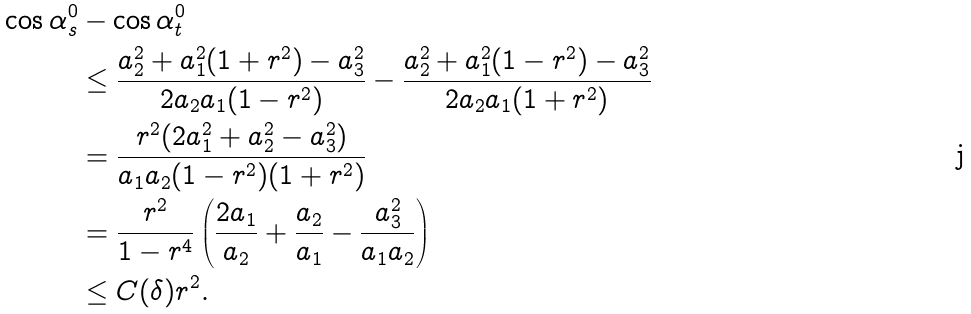<formula> <loc_0><loc_0><loc_500><loc_500>\cos \alpha _ { s } ^ { 0 } & - \cos \alpha _ { t } ^ { 0 } \\ & \leq \frac { a _ { 2 } ^ { 2 } + a _ { 1 } ^ { 2 } ( 1 + r ^ { 2 } ) - a _ { 3 } ^ { 2 } } { 2 a _ { 2 } a _ { 1 } ( 1 - r ^ { 2 } ) } - \frac { a _ { 2 } ^ { 2 } + a _ { 1 } ^ { 2 } ( 1 - r ^ { 2 } ) - a _ { 3 } ^ { 2 } } { 2 a _ { 2 } a _ { 1 } ( 1 + r ^ { 2 } ) } \\ & = \frac { r ^ { 2 } ( 2 a _ { 1 } ^ { 2 } + a _ { 2 } ^ { 2 } - a _ { 3 } ^ { 2 } ) } { a _ { 1 } a _ { 2 } ( 1 - r ^ { 2 } ) ( 1 + r ^ { 2 } ) } \\ & = \frac { r ^ { 2 } } { 1 - r ^ { 4 } } \left ( \frac { 2 a _ { 1 } } { a _ { 2 } } + \frac { a _ { 2 } } { a _ { 1 } } - \frac { a _ { 3 } ^ { 2 } } { a _ { 1 } a _ { 2 } } \right ) \\ & \leq C ( \delta ) r ^ { 2 } .</formula> 